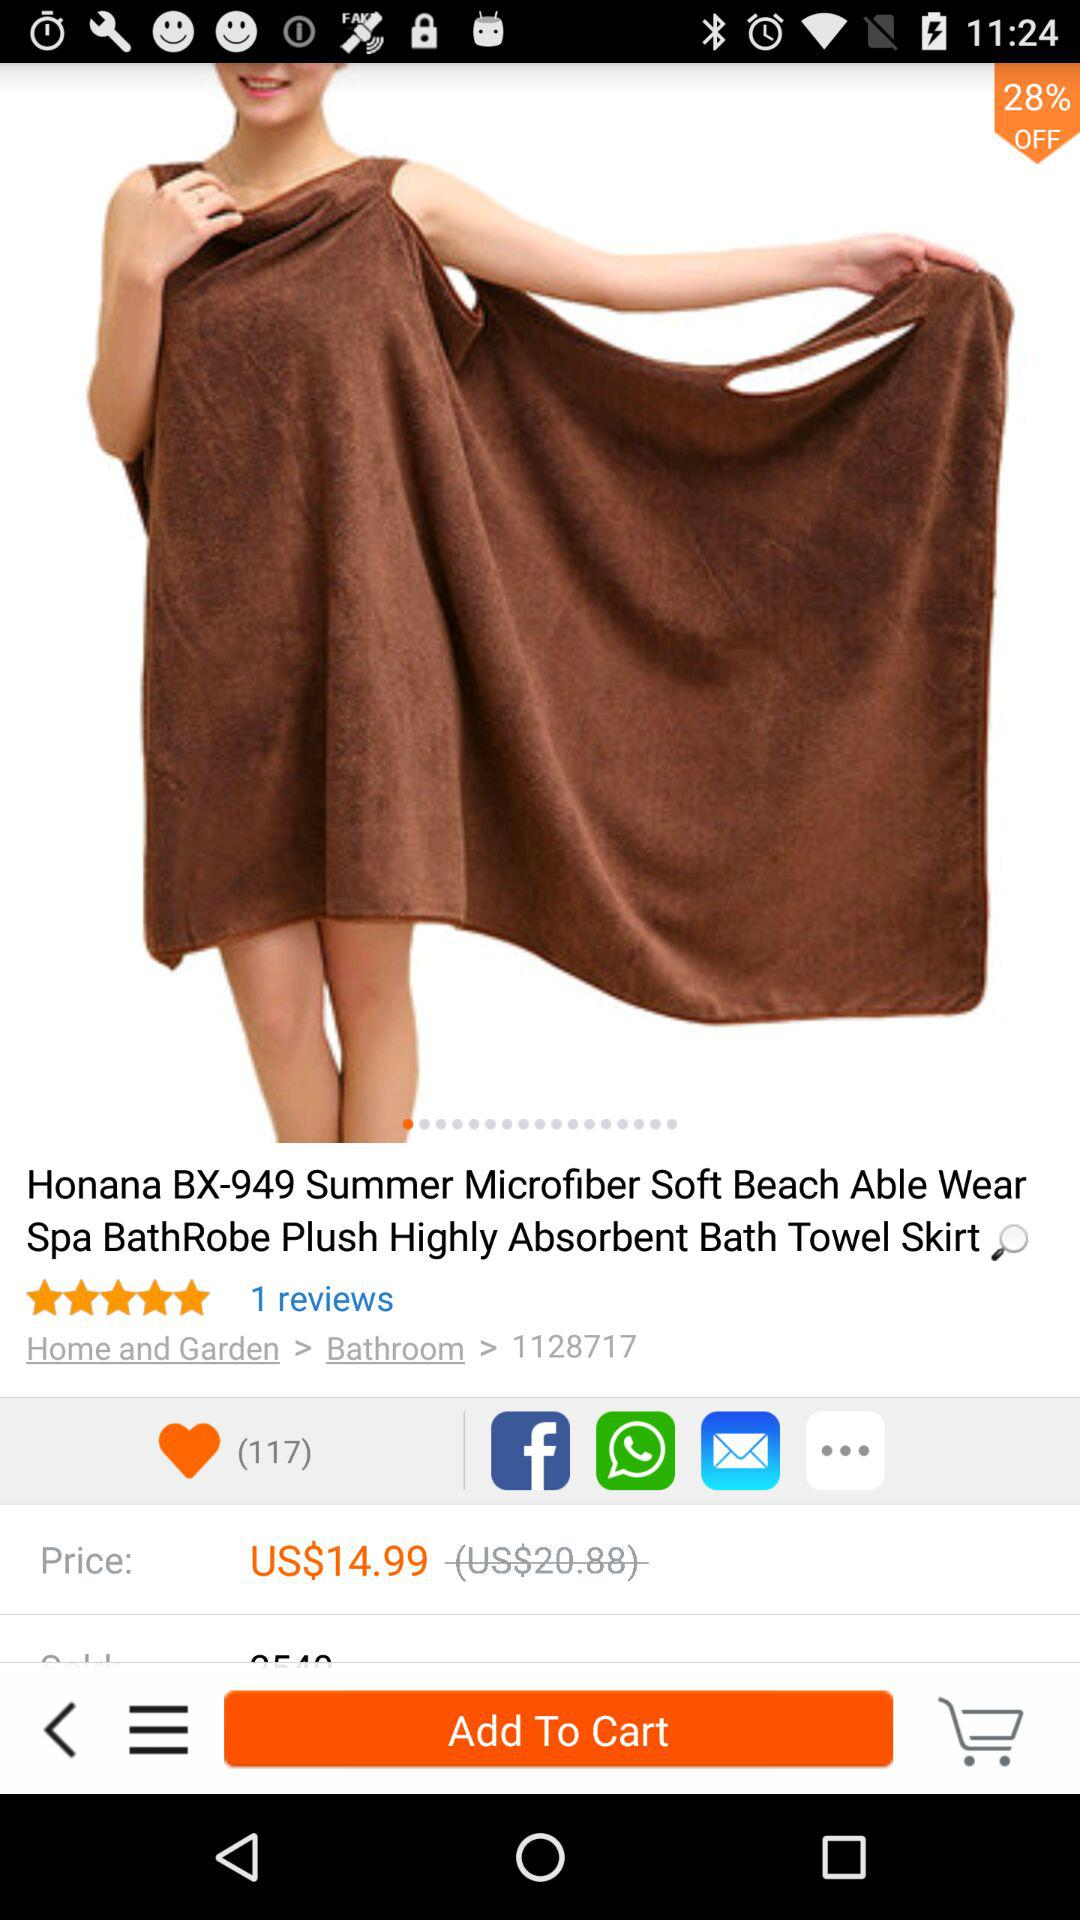What's the price after offer? The price after the offer is US$14.99. 